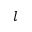<formula> <loc_0><loc_0><loc_500><loc_500>l</formula> 